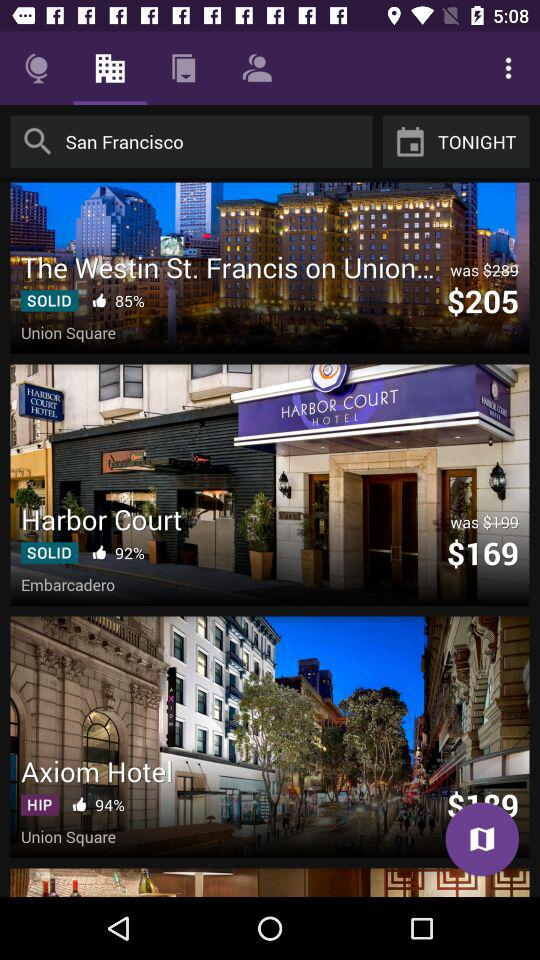What location is entered in the search bar? The location entered in the search bar is San Francisco. 